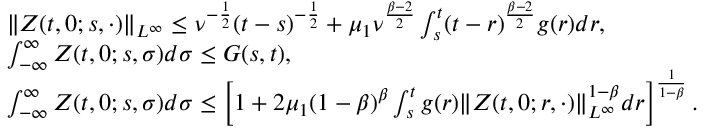<formula> <loc_0><loc_0><loc_500><loc_500>\begin{array} { r l } & { \| Z ( t , 0 ; s , \cdot ) \| _ { L ^ { \infty } } \leq \nu ^ { - \frac { 1 } { 2 } } ( t - s ) ^ { - \frac { 1 } { 2 } } + \mu _ { 1 } \nu ^ { \frac { \beta - 2 } { 2 } } \int _ { s } ^ { t } ( t - r ) ^ { \frac { \beta - 2 } { 2 } } g ( r ) d r , } \\ & { \int _ { - \infty } ^ { \infty } Z ( t , 0 ; s , \sigma ) d \sigma \leq G ( s , t ) , } \\ & { \int _ { - \infty } ^ { \infty } Z ( t , 0 ; s , \sigma ) d \sigma \leq \left [ 1 + 2 \mu _ { 1 } ( 1 - \beta ) ^ { \beta } \int _ { s } ^ { t } g ( r ) \| Z ( t , 0 ; r , \cdot ) \| _ { L ^ { \infty } } ^ { 1 - \beta } d r \right ] ^ { \frac { 1 } { 1 - \beta } } . } \end{array}</formula> 